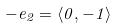<formula> <loc_0><loc_0><loc_500><loc_500>- e _ { 2 } = \langle 0 , - 1 \rangle</formula> 